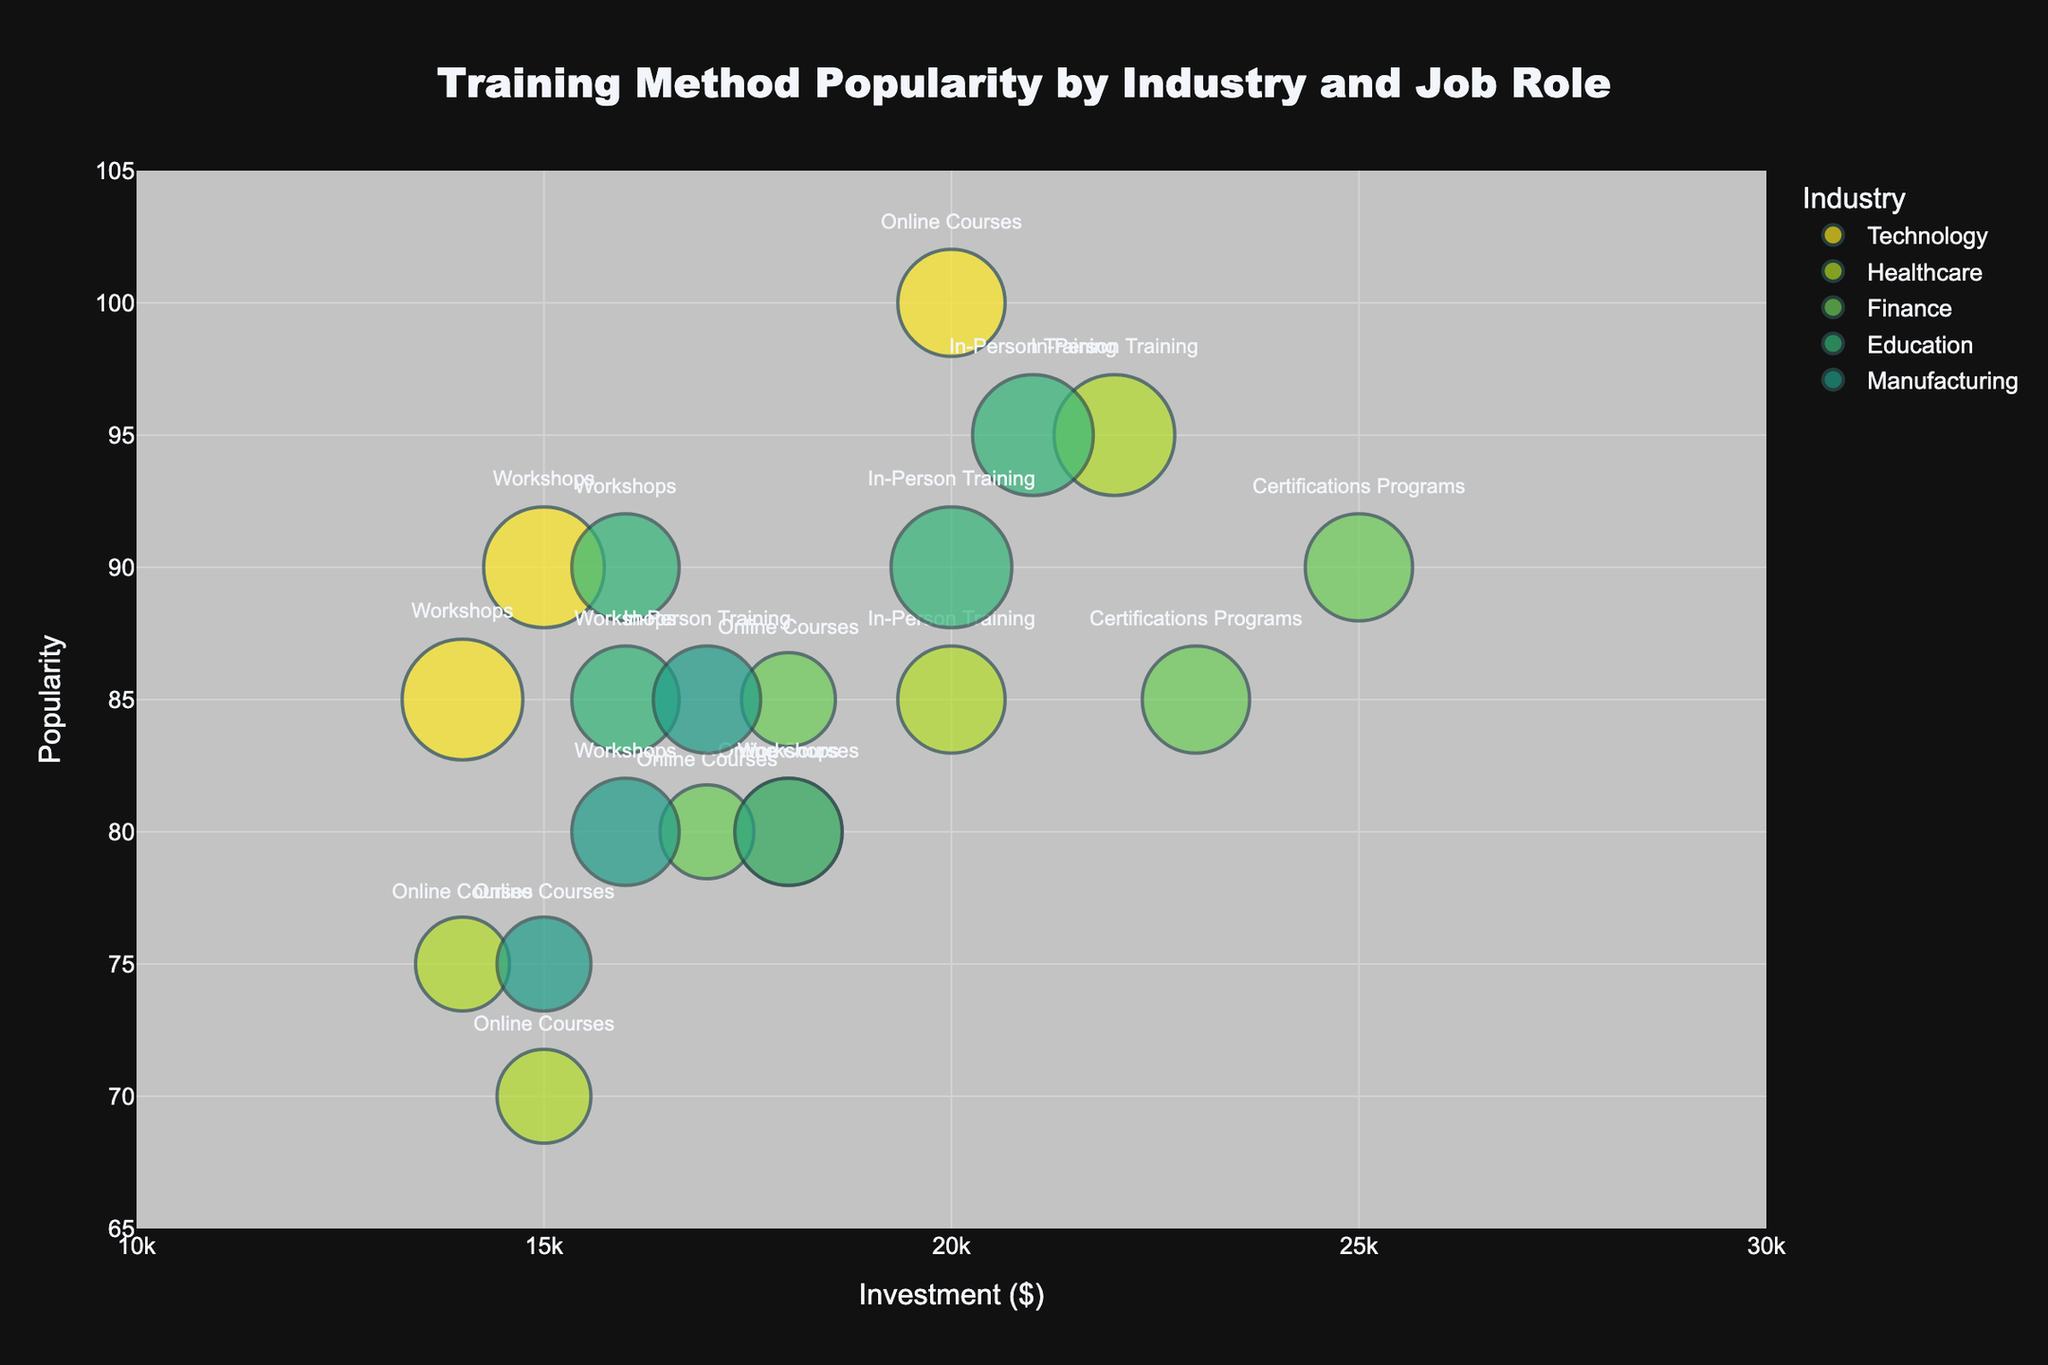What's the title of the figure? The title is usually displayed at the top of the figure. By looking at the top center, we see "Training Method Popularity by Industry and Job Role."
Answer: Training Method Popularity by Industry and Job Role What are the x-axis and y-axis labels? The labels for the axes are located along the grid lines at the bottom and side of the figure. The x-axis is labeled "Investment ($)" and the y-axis is labeled "Popularity."
Answer: Investment ($) and Popularity Which industry has the highest overall popularity for training methods? Look at the y-axis and find the highest position of bubbles. Bubbles with the highest y-coordinate represent the highest popularity. Here, Healthcare, Education, and Technology industries have bubbles in the highest positions closely tied around 90-95 popularity.
Answer: Healthcare, Education, and Technology What is the most popular training method for Nurses in the Healthcare industry? Find the bubble where the "Hover Name" or "Job Role" is "Nurse" and the "Industry" is "Healthcare." Check the text label within the bubble to identify the training method. The bubble at the highest position (95 popularity) reads "In-Person Training."
Answer: In-Person Training Compare the investment in training methods between Software Developers in the Technology industry and Financial Analysts in the Finance industry. Which one has a higher maximum investment? Look at the x-axis position for bubbles labeled "Software Developer" and "Financial Analyst." The Software Developer methods' investments ($) are 20,000 and 15,000, whereas for Financial Analysts, they are 25,000 and 18,000. Thus, Financial Analysts have a higher maximum investment.
Answer: Financial Analyst For which job role in the Finance industry is the popularity of online courses greater than that of certification programs? Look for bubbles where the "Job Role" is either "Financial Analyst" or "Accountant" in the Finance industry and compare the popularity values on the y-axis for Online Courses and Certification Programs. The bubble for "Financial Analyst" and "Online Courses" (popularity 85) is greater than Certification Programs for the same job role (popularity 90).
Answer: None What is the average investment across all training methods in the Technology industry? Sum the investment values for all bubbles with "Industry" as "Technology" and divide by the number of such bubbles: (20,000 + 15,000 + 18,000 + 14,000)/(4 bubbles) = 67,000/4 = 16,750.
Answer: 16,750 Which industry has the widest range of investment in training methods? Compare the maximum and minimum investment values for each industry. Calculate the range for each (max - min): 
- Technology: 20,000 - 14,000 = 6,000
- Healthcare: 22,000 - 14,000 = 8,000
- Finance: 25,000 - 17,000 = 8,000
- Education: 21,000 - 16,000 = 5,000
- Manufacturing: 18,000 - 15,000 = 3,000
The widest range is 8,000 applicable to Healthcare and Finance.
Answer: Healthcare and Finance Within the Education industry, which job role's training method requires the least investment? Look for the smallest x-axis position among the bubbles labeled "Teacher" and "Administrator" within the Education industry. The bubble for "Teacher" and "Workshops" sits at $16,000 which is the lowest among Education roles.
Answer: Teacher (Workshops) How does the effectiveness of workshops compare between Engineers in Manufacturing and Data Scientists in Technology? Identify the bubbles for "Engineer" and "Data Scientist" with "Workshops" and compare their sizes (representing effectiveness). Both "Engineer" and "Data Scientist" have workshops at effectiveness levels of 8 and 9 respectively. Hence, Data Scientists’ workshops are slightly more effective.
Answer: Data Scientists have higher effectiveness 